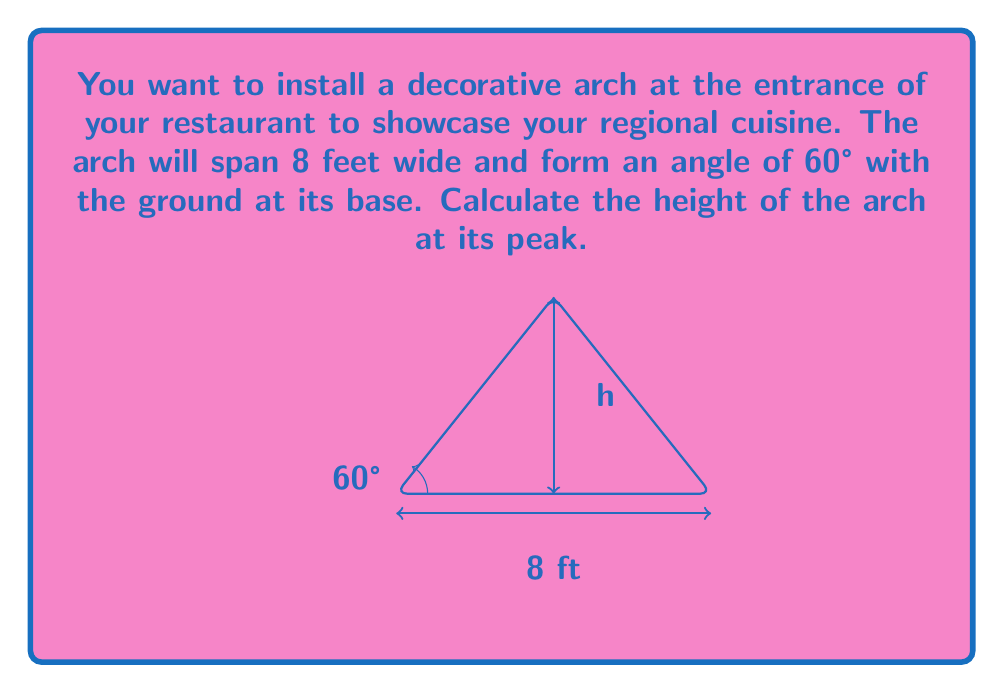Teach me how to tackle this problem. Let's approach this step-by-step using trigonometry:

1) The arch forms an isosceles triangle, with the 8-foot span as the base and the height we're seeking as the altitude.

2) We can split this isosceles triangle into two right triangles. Let's focus on one of these right triangles.

3) In this right triangle:
   - The base is half of the total span: $\frac{8}{2} = 4$ feet
   - The angle at the base is 60°
   - We're looking for the height, which is the opposite side to this angle

4) We can use the tangent ratio:

   $\tan \theta = \frac{\text{opposite}}{\text{adjacent}}$

5) Plugging in our values:

   $\tan 60° = \frac{h}{4}$

6) We know that $\tan 60° = \sqrt{3}$, so:

   $\sqrt{3} = \frac{h}{4}$

7) Solving for h:

   $h = 4\sqrt{3}$

8) To get a decimal approximation:

   $h \approx 4 * 1.732 \approx 6.928$ feet

Therefore, the height of the arch at its peak is $4\sqrt{3}$ feet, or approximately 6.93 feet.
Answer: $4\sqrt{3}$ feet (≈ 6.93 feet) 